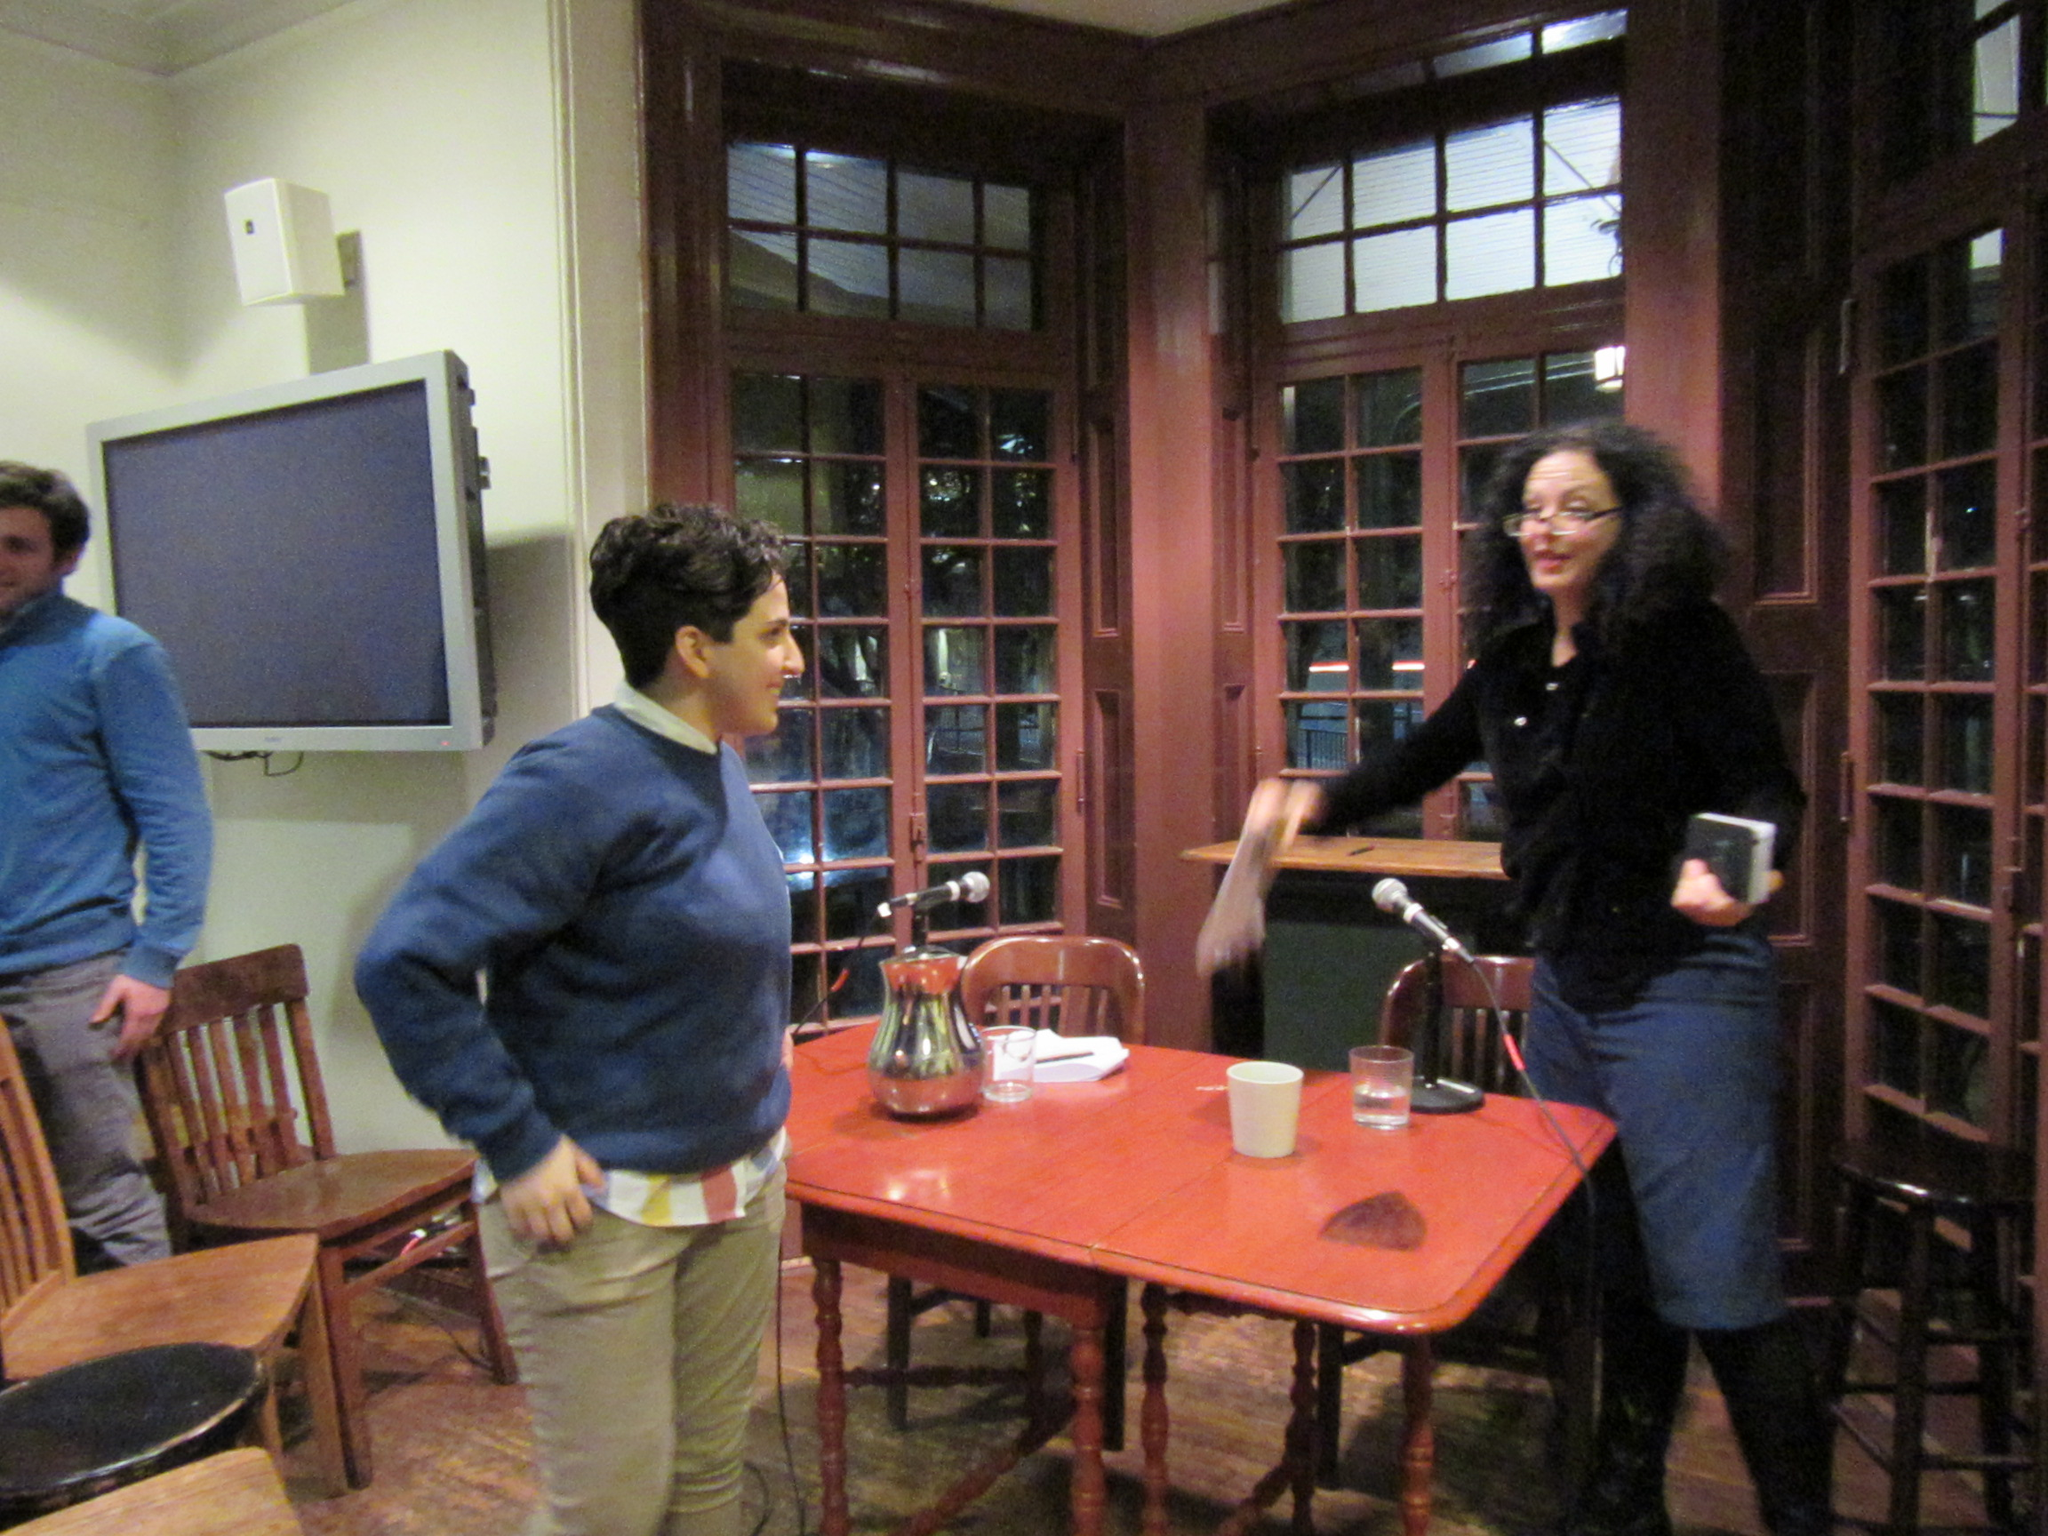Please provide a concise description of this image. In this picture we can see two woman and one man standing where two woman are talking to each other and in front of them on table we have jar, glass with water in it, mics and aside to this table we have chairs and in the background we can see television, windows. 